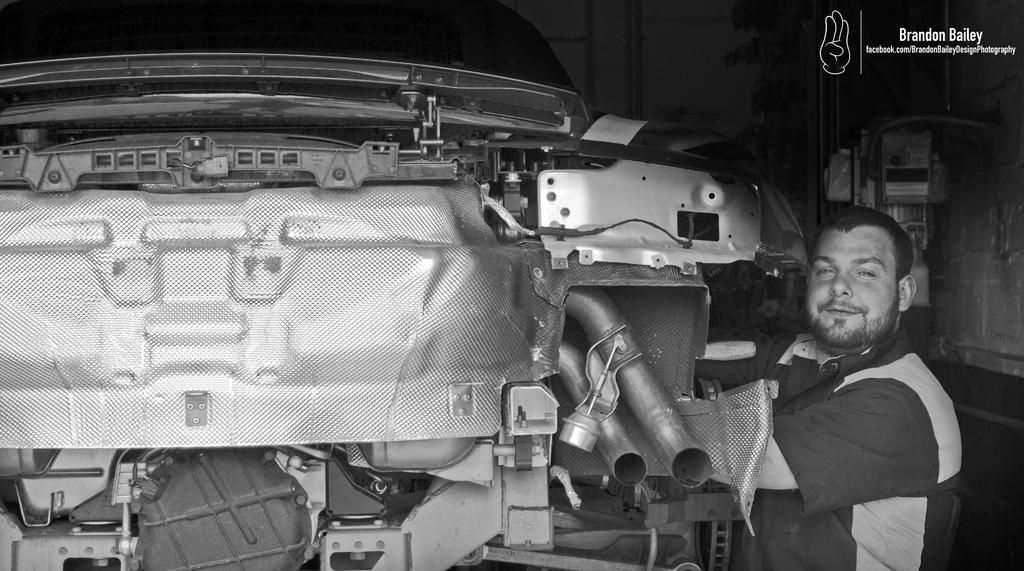What is the man in the image doing? The man is standing in the image and smiling. What else can be seen in the image besides the man? There is a vehicle in the image. How would you describe the background of the image? The background of the image is dark. Are there any other objects or features visible in the background? Yes, there is an object and a wall in the background. What type of cork can be seen in the image? There is no cork present in the image. Is there a group of people standing near the man in the image? The image only shows a single man standing, so there is no group of people present. 